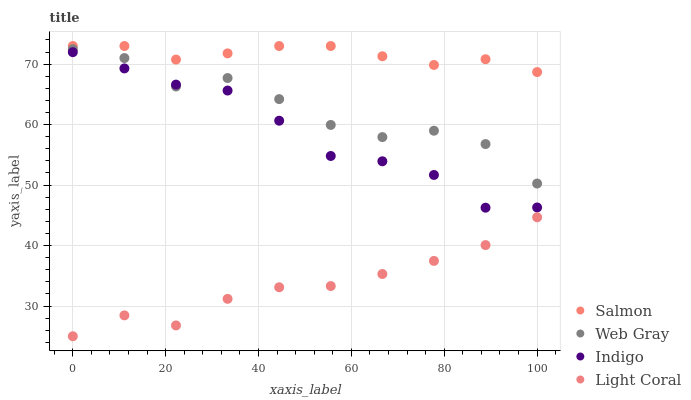Does Light Coral have the minimum area under the curve?
Answer yes or no. Yes. Does Salmon have the maximum area under the curve?
Answer yes or no. Yes. Does Indigo have the minimum area under the curve?
Answer yes or no. No. Does Indigo have the maximum area under the curve?
Answer yes or no. No. Is Salmon the smoothest?
Answer yes or no. Yes. Is Web Gray the roughest?
Answer yes or no. Yes. Is Indigo the smoothest?
Answer yes or no. No. Is Indigo the roughest?
Answer yes or no. No. Does Light Coral have the lowest value?
Answer yes or no. Yes. Does Indigo have the lowest value?
Answer yes or no. No. Does Salmon have the highest value?
Answer yes or no. Yes. Does Indigo have the highest value?
Answer yes or no. No. Is Web Gray less than Salmon?
Answer yes or no. Yes. Is Indigo greater than Light Coral?
Answer yes or no. Yes. Does Web Gray intersect Indigo?
Answer yes or no. Yes. Is Web Gray less than Indigo?
Answer yes or no. No. Is Web Gray greater than Indigo?
Answer yes or no. No. Does Web Gray intersect Salmon?
Answer yes or no. No. 